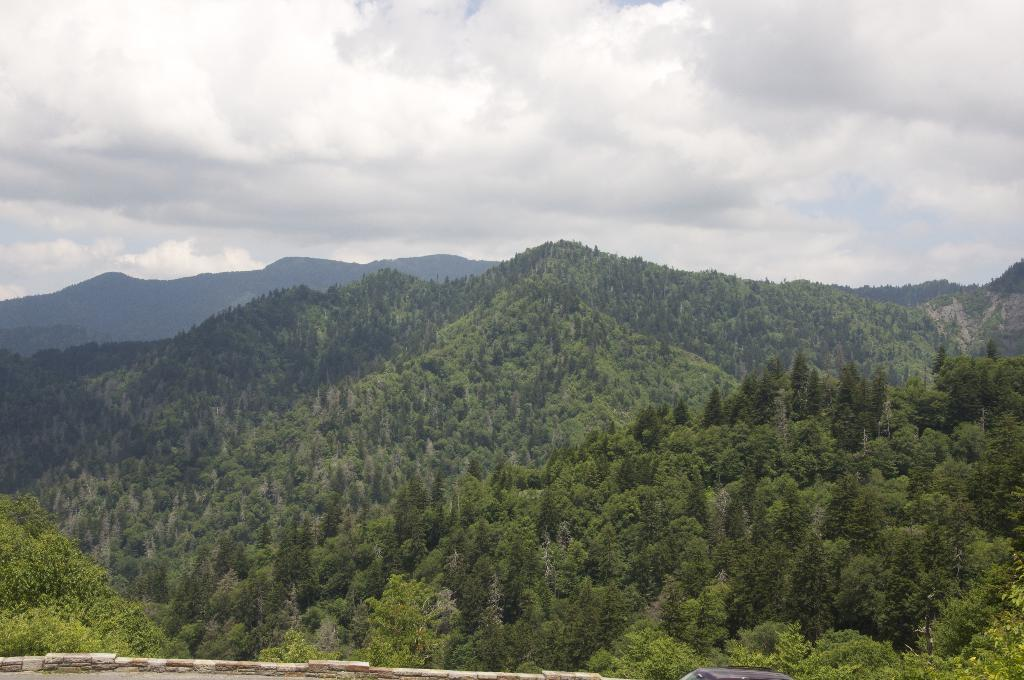What is located at the front of the image? There is a wall in the front of the image. Can you describe the color of any object in the image? There is an object that is black in color in the image. What can be seen in the background of the image? There are trees and mountains in the background of the image. How would you describe the sky in the image? The sky is cloudy in the image. Who is the owner of the spiders in the image? There are no spiders present in the image, so there is no owner to consider. 